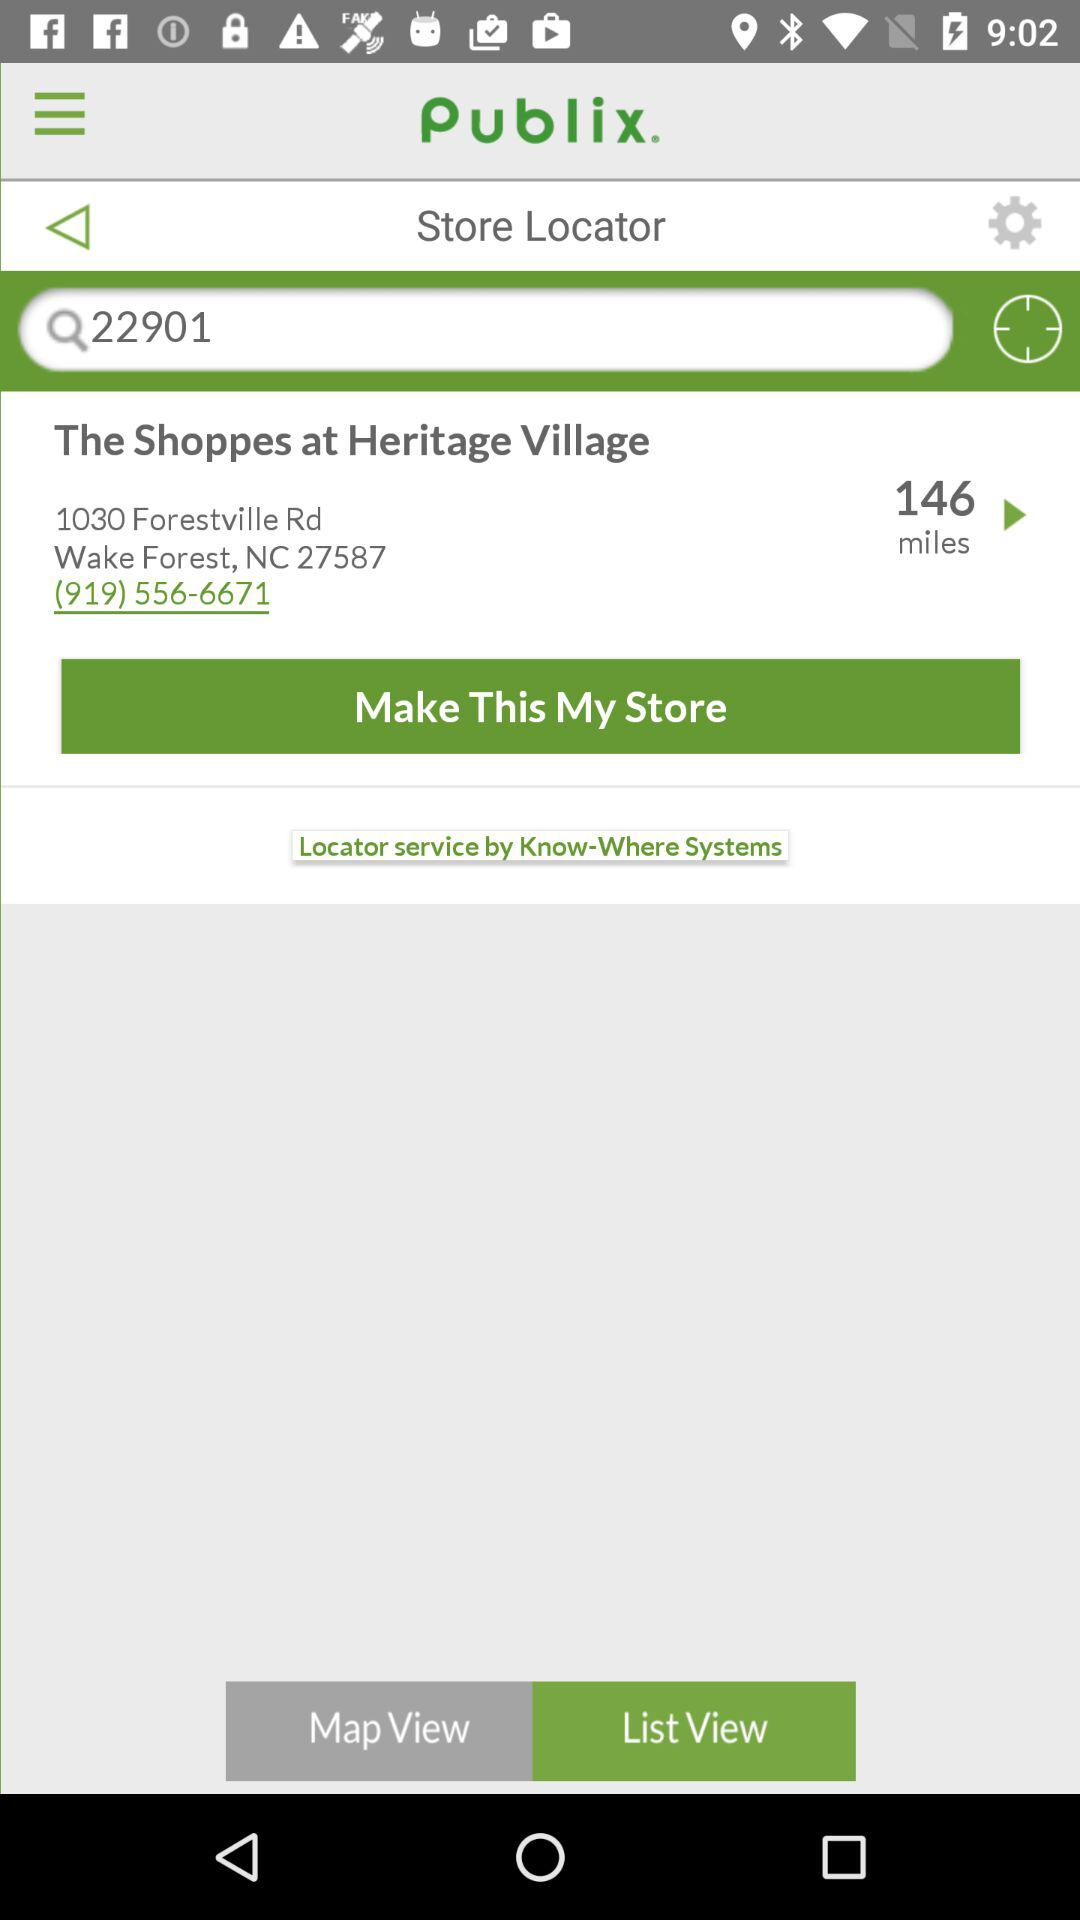What is the phone number of the store?
Answer the question using a single word or phrase. (919) 556-6671 